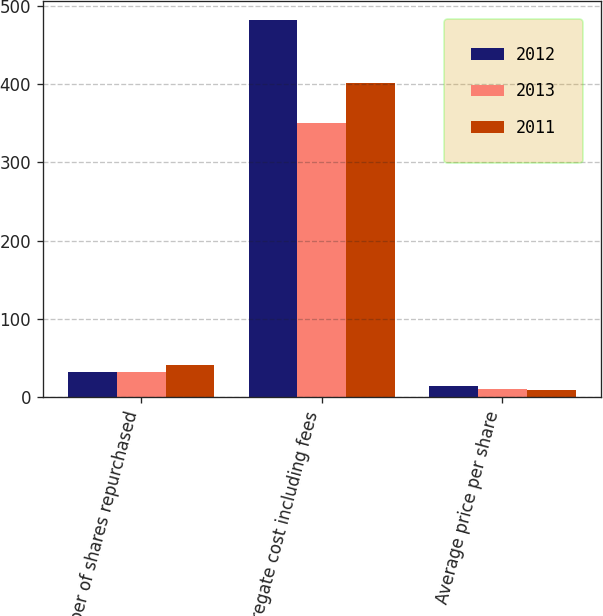Convert chart. <chart><loc_0><loc_0><loc_500><loc_500><stacked_bar_chart><ecel><fcel>Number of shares repurchased<fcel>Aggregate cost including fees<fcel>Average price per share<nl><fcel>2012<fcel>31.8<fcel>481.8<fcel>15.17<nl><fcel>2013<fcel>32.7<fcel>350.5<fcel>10.72<nl><fcel>2011<fcel>41.7<fcel>400.8<fcel>9.62<nl></chart> 